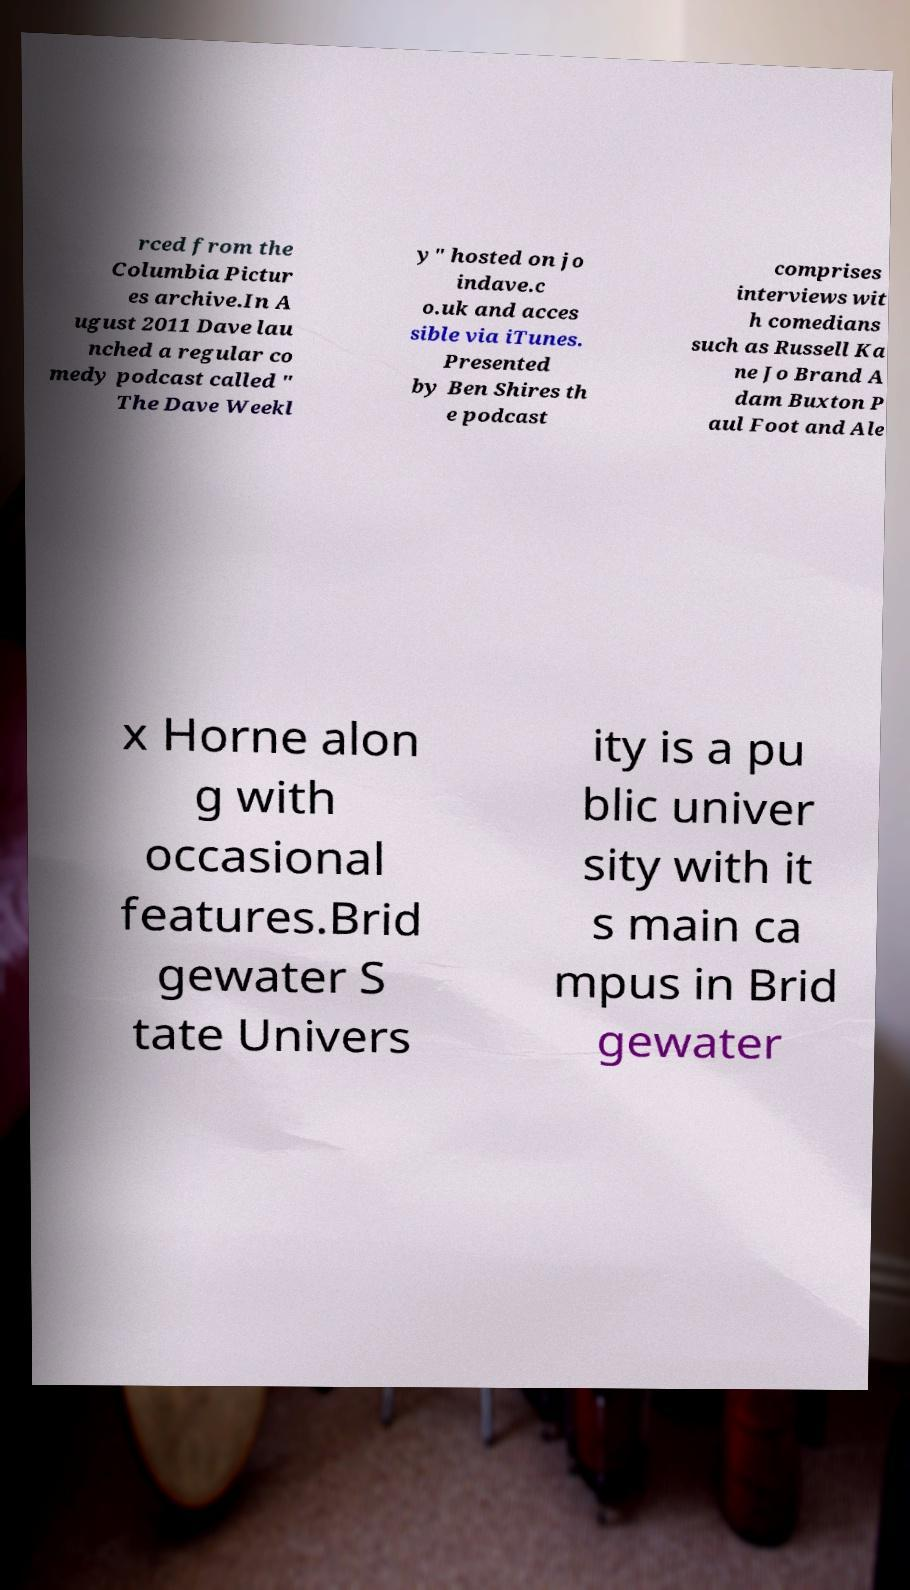Could you extract and type out the text from this image? rced from the Columbia Pictur es archive.In A ugust 2011 Dave lau nched a regular co medy podcast called " The Dave Weekl y" hosted on jo indave.c o.uk and acces sible via iTunes. Presented by Ben Shires th e podcast comprises interviews wit h comedians such as Russell Ka ne Jo Brand A dam Buxton P aul Foot and Ale x Horne alon g with occasional features.Brid gewater S tate Univers ity is a pu blic univer sity with it s main ca mpus in Brid gewater 